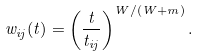<formula> <loc_0><loc_0><loc_500><loc_500>w _ { i j } ( t ) = \left ( \frac { t } { t _ { i j } } \right ) ^ { W / ( W + m ) } .</formula> 